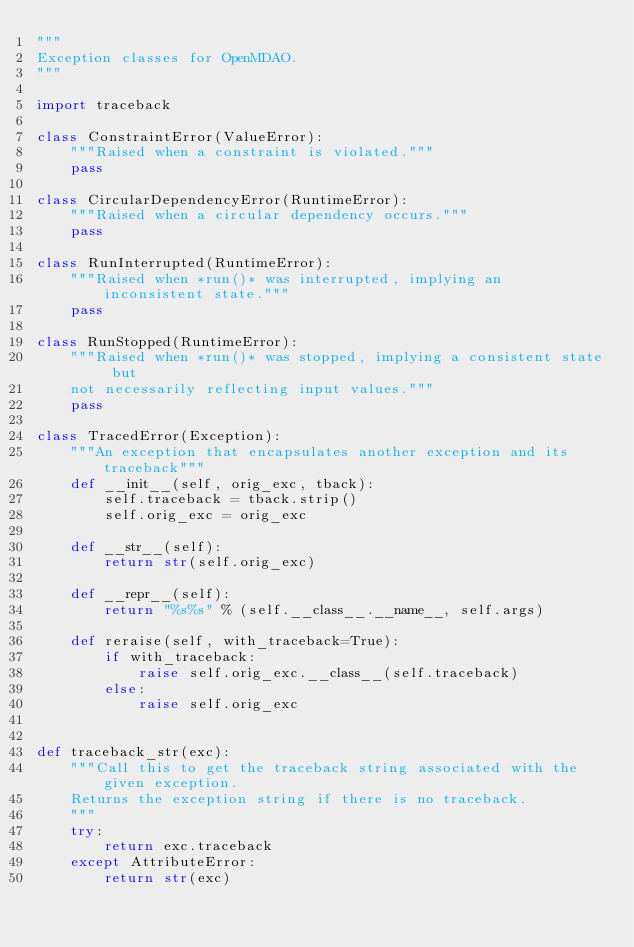<code> <loc_0><loc_0><loc_500><loc_500><_Python_>"""
Exception classes for OpenMDAO.
"""

import traceback

class ConstraintError(ValueError):
    """Raised when a constraint is violated."""
    pass
        
class CircularDependencyError(RuntimeError):
    """Raised when a circular dependency occurs."""
    pass
        
class RunInterrupted(RuntimeError):
    """Raised when *run()* was interrupted, implying an inconsistent state."""
    pass

class RunStopped(RuntimeError):
    """Raised when *run()* was stopped, implying a consistent state but
    not necessarily reflecting input values."""
    pass

class TracedError(Exception):
    """An exception that encapsulates another exception and its traceback"""
    def __init__(self, orig_exc, tback):
        self.traceback = tback.strip()
        self.orig_exc = orig_exc
    
    def __str__(self):
        return str(self.orig_exc)
    
    def __repr__(self):
        return "%s%s" % (self.__class__.__name__, self.args)
    
    def reraise(self, with_traceback=True):
        if with_traceback:
            raise self.orig_exc.__class__(self.traceback)
        else:
            raise self.orig_exc
    

def traceback_str(exc):
    """Call this to get the traceback string associated with the given exception.
    Returns the exception string if there is no traceback.
    """
    try:
        return exc.traceback
    except AttributeError:
        return str(exc)

</code> 